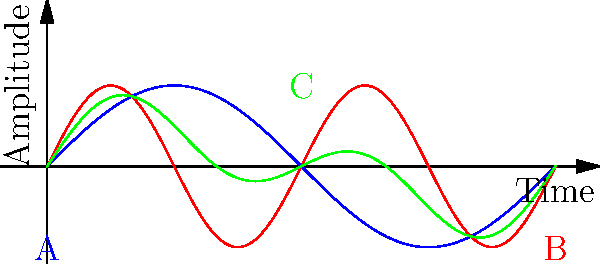In electronic music production, particularly in Dardust's style, waveform transformation is crucial. The graph shows three waveforms: A (blue), B (red), and C (green). If A represents a sine wave and B represents its first harmonic, which group theory operation best describes the transformation from A and B to C? To answer this question, let's analyze the waveforms step-by-step:

1. Waveform A (blue) is a standard sine wave, represented by the function $f_1(x) = \sin(x)$.

2. Waveform B (red) is the first harmonic of A, which has twice the frequency. It can be represented by the function $f_2(x) = \sin(2x)$.

3. Waveform C (green) appears to be a combination of A and B.

4. To determine the exact relationship, we need to consider common waveform transformations in electronic music production.

5. The most likely transformation here is addition with scaling. Specifically, C looks like it's formed by adding A and B together, but each with half the original amplitude.

6. We can represent this mathematically as:
   $f_3(x) = 0.5f_1(x) + 0.5f_2(x) = 0.5\sin(x) + 0.5\sin(2x)$

7. In group theory, this operation is known as a linear combination, which is a form of superposition.

8. Superposition is a key principle in electronic music production, especially in additive synthesis, which is often used in Dardust's style of music.

Therefore, the group theory operation that best describes this transformation is superposition, specifically a linear combination with equal weights.
Answer: Superposition (Linear combination) 